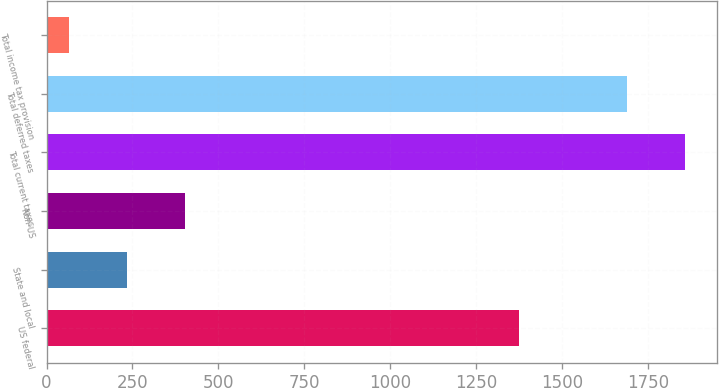Convert chart. <chart><loc_0><loc_0><loc_500><loc_500><bar_chart><fcel>US federal<fcel>State and local<fcel>Non-US<fcel>Total current taxes<fcel>Total deferred taxes<fcel>Total income tax provision<nl><fcel>1376<fcel>234<fcel>403<fcel>1859<fcel>1690<fcel>65<nl></chart> 